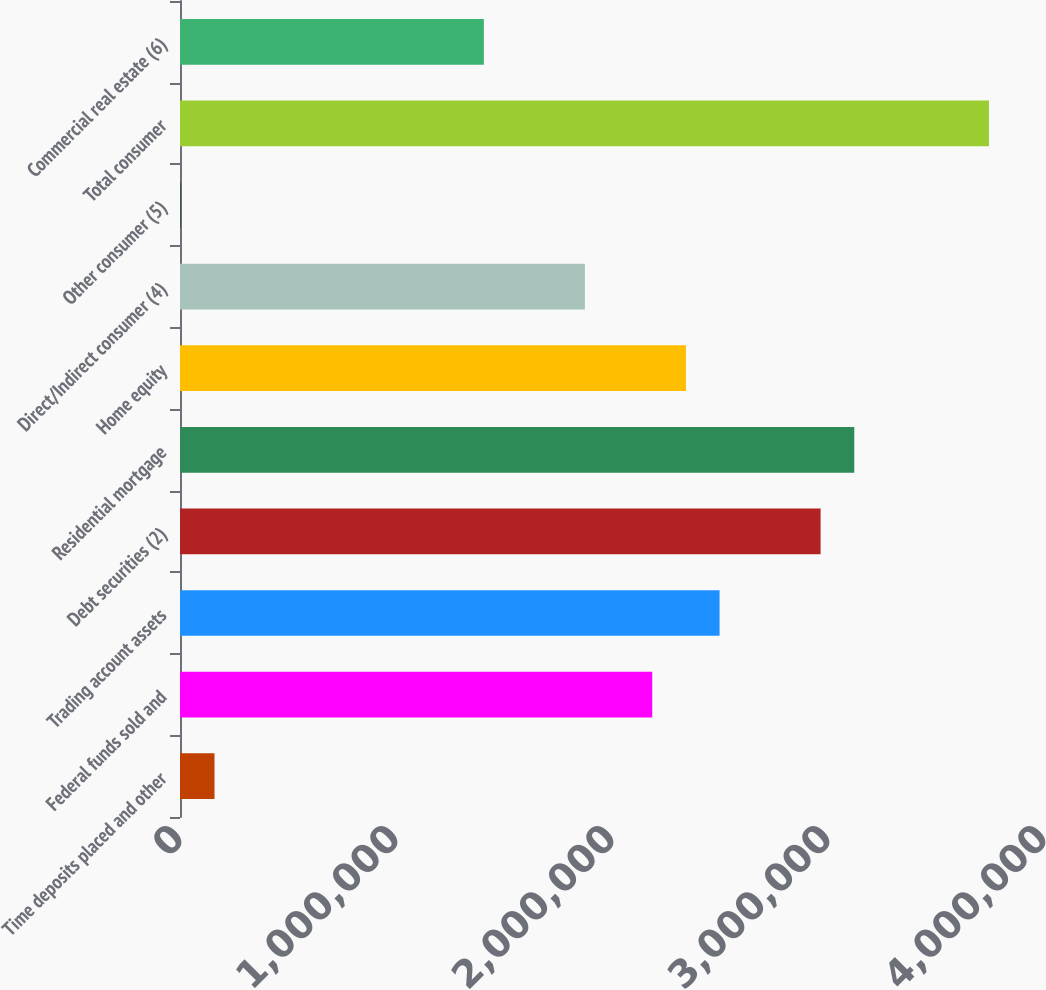Convert chart to OTSL. <chart><loc_0><loc_0><loc_500><loc_500><bar_chart><fcel>Time deposits placed and other<fcel>Federal funds sold and<fcel>Trading account assets<fcel>Debt securities (2)<fcel>Residential mortgage<fcel>Home equity<fcel>Direct/Indirect consumer (4)<fcel>Other consumer (5)<fcel>Total consumer<fcel>Commercial real estate (6)<nl><fcel>159707<fcel>2.18629e+06<fcel>2.49808e+06<fcel>2.96575e+06<fcel>3.12164e+06<fcel>2.34219e+06<fcel>1.87451e+06<fcel>3816<fcel>3.74521e+06<fcel>1.40684e+06<nl></chart> 